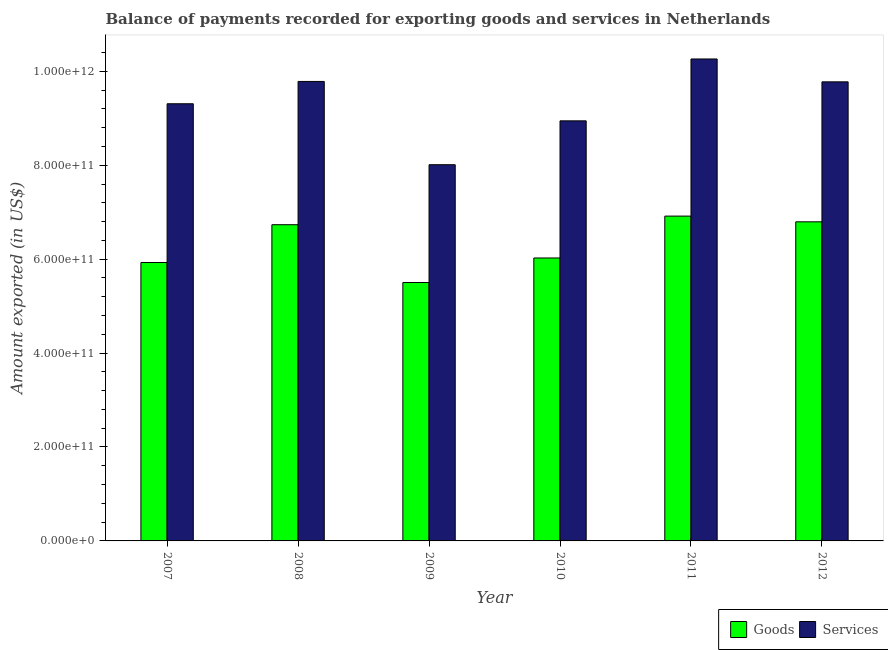How many different coloured bars are there?
Ensure brevity in your answer.  2. Are the number of bars per tick equal to the number of legend labels?
Keep it short and to the point. Yes. Are the number of bars on each tick of the X-axis equal?
Ensure brevity in your answer.  Yes. What is the label of the 3rd group of bars from the left?
Offer a very short reply. 2009. What is the amount of goods exported in 2011?
Your response must be concise. 6.92e+11. Across all years, what is the maximum amount of goods exported?
Provide a succinct answer. 6.92e+11. Across all years, what is the minimum amount of services exported?
Your answer should be compact. 8.01e+11. In which year was the amount of services exported maximum?
Offer a very short reply. 2011. What is the total amount of goods exported in the graph?
Keep it short and to the point. 3.79e+12. What is the difference between the amount of services exported in 2007 and that in 2012?
Provide a succinct answer. -4.67e+1. What is the difference between the amount of services exported in 2012 and the amount of goods exported in 2007?
Provide a succinct answer. 4.67e+1. What is the average amount of goods exported per year?
Provide a succinct answer. 6.32e+11. What is the ratio of the amount of goods exported in 2007 to that in 2011?
Your answer should be compact. 0.86. What is the difference between the highest and the second highest amount of goods exported?
Your answer should be compact. 1.22e+1. What is the difference between the highest and the lowest amount of goods exported?
Your response must be concise. 1.41e+11. In how many years, is the amount of services exported greater than the average amount of services exported taken over all years?
Offer a very short reply. 3. What does the 1st bar from the left in 2009 represents?
Your answer should be compact. Goods. What does the 2nd bar from the right in 2007 represents?
Your answer should be compact. Goods. How many bars are there?
Your answer should be very brief. 12. Are all the bars in the graph horizontal?
Your answer should be compact. No. How many years are there in the graph?
Give a very brief answer. 6. What is the difference between two consecutive major ticks on the Y-axis?
Provide a short and direct response. 2.00e+11. Are the values on the major ticks of Y-axis written in scientific E-notation?
Give a very brief answer. Yes. Where does the legend appear in the graph?
Your answer should be compact. Bottom right. How many legend labels are there?
Provide a short and direct response. 2. How are the legend labels stacked?
Provide a succinct answer. Horizontal. What is the title of the graph?
Keep it short and to the point. Balance of payments recorded for exporting goods and services in Netherlands. Does "Start a business" appear as one of the legend labels in the graph?
Your response must be concise. No. What is the label or title of the X-axis?
Provide a short and direct response. Year. What is the label or title of the Y-axis?
Provide a short and direct response. Amount exported (in US$). What is the Amount exported (in US$) of Goods in 2007?
Your answer should be compact. 5.93e+11. What is the Amount exported (in US$) of Services in 2007?
Provide a short and direct response. 9.31e+11. What is the Amount exported (in US$) of Goods in 2008?
Ensure brevity in your answer.  6.73e+11. What is the Amount exported (in US$) of Services in 2008?
Provide a succinct answer. 9.78e+11. What is the Amount exported (in US$) in Goods in 2009?
Your response must be concise. 5.50e+11. What is the Amount exported (in US$) in Services in 2009?
Provide a short and direct response. 8.01e+11. What is the Amount exported (in US$) in Goods in 2010?
Make the answer very short. 6.03e+11. What is the Amount exported (in US$) in Services in 2010?
Provide a short and direct response. 8.95e+11. What is the Amount exported (in US$) in Goods in 2011?
Your answer should be compact. 6.92e+11. What is the Amount exported (in US$) of Services in 2011?
Your response must be concise. 1.03e+12. What is the Amount exported (in US$) in Goods in 2012?
Offer a very short reply. 6.79e+11. What is the Amount exported (in US$) of Services in 2012?
Provide a succinct answer. 9.78e+11. Across all years, what is the maximum Amount exported (in US$) in Goods?
Your answer should be compact. 6.92e+11. Across all years, what is the maximum Amount exported (in US$) in Services?
Offer a very short reply. 1.03e+12. Across all years, what is the minimum Amount exported (in US$) of Goods?
Offer a terse response. 5.50e+11. Across all years, what is the minimum Amount exported (in US$) in Services?
Keep it short and to the point. 8.01e+11. What is the total Amount exported (in US$) in Goods in the graph?
Provide a succinct answer. 3.79e+12. What is the total Amount exported (in US$) in Services in the graph?
Your answer should be compact. 5.61e+12. What is the difference between the Amount exported (in US$) in Goods in 2007 and that in 2008?
Offer a very short reply. -8.05e+1. What is the difference between the Amount exported (in US$) of Services in 2007 and that in 2008?
Your answer should be very brief. -4.75e+1. What is the difference between the Amount exported (in US$) of Goods in 2007 and that in 2009?
Your answer should be very brief. 4.26e+1. What is the difference between the Amount exported (in US$) in Services in 2007 and that in 2009?
Make the answer very short. 1.30e+11. What is the difference between the Amount exported (in US$) in Goods in 2007 and that in 2010?
Offer a very short reply. -9.65e+09. What is the difference between the Amount exported (in US$) of Services in 2007 and that in 2010?
Your answer should be compact. 3.64e+1. What is the difference between the Amount exported (in US$) of Goods in 2007 and that in 2011?
Your response must be concise. -9.88e+1. What is the difference between the Amount exported (in US$) in Services in 2007 and that in 2011?
Keep it short and to the point. -9.54e+1. What is the difference between the Amount exported (in US$) in Goods in 2007 and that in 2012?
Your answer should be very brief. -8.66e+1. What is the difference between the Amount exported (in US$) of Services in 2007 and that in 2012?
Your response must be concise. -4.67e+1. What is the difference between the Amount exported (in US$) of Goods in 2008 and that in 2009?
Your answer should be very brief. 1.23e+11. What is the difference between the Amount exported (in US$) in Services in 2008 and that in 2009?
Your answer should be very brief. 1.77e+11. What is the difference between the Amount exported (in US$) of Goods in 2008 and that in 2010?
Make the answer very short. 7.08e+1. What is the difference between the Amount exported (in US$) of Services in 2008 and that in 2010?
Provide a succinct answer. 8.39e+1. What is the difference between the Amount exported (in US$) of Goods in 2008 and that in 2011?
Provide a short and direct response. -1.83e+1. What is the difference between the Amount exported (in US$) of Services in 2008 and that in 2011?
Offer a terse response. -4.79e+1. What is the difference between the Amount exported (in US$) in Goods in 2008 and that in 2012?
Provide a succinct answer. -6.14e+09. What is the difference between the Amount exported (in US$) in Services in 2008 and that in 2012?
Offer a very short reply. 8.37e+08. What is the difference between the Amount exported (in US$) of Goods in 2009 and that in 2010?
Your answer should be compact. -5.22e+1. What is the difference between the Amount exported (in US$) of Services in 2009 and that in 2010?
Ensure brevity in your answer.  -9.34e+1. What is the difference between the Amount exported (in US$) of Goods in 2009 and that in 2011?
Offer a terse response. -1.41e+11. What is the difference between the Amount exported (in US$) of Services in 2009 and that in 2011?
Your answer should be very brief. -2.25e+11. What is the difference between the Amount exported (in US$) of Goods in 2009 and that in 2012?
Provide a succinct answer. -1.29e+11. What is the difference between the Amount exported (in US$) of Services in 2009 and that in 2012?
Give a very brief answer. -1.76e+11. What is the difference between the Amount exported (in US$) in Goods in 2010 and that in 2011?
Your answer should be very brief. -8.92e+1. What is the difference between the Amount exported (in US$) in Services in 2010 and that in 2011?
Provide a succinct answer. -1.32e+11. What is the difference between the Amount exported (in US$) in Goods in 2010 and that in 2012?
Provide a succinct answer. -7.70e+1. What is the difference between the Amount exported (in US$) in Services in 2010 and that in 2012?
Your answer should be compact. -8.30e+1. What is the difference between the Amount exported (in US$) in Goods in 2011 and that in 2012?
Provide a succinct answer. 1.22e+1. What is the difference between the Amount exported (in US$) in Services in 2011 and that in 2012?
Provide a succinct answer. 4.87e+1. What is the difference between the Amount exported (in US$) in Goods in 2007 and the Amount exported (in US$) in Services in 2008?
Make the answer very short. -3.86e+11. What is the difference between the Amount exported (in US$) of Goods in 2007 and the Amount exported (in US$) of Services in 2009?
Provide a succinct answer. -2.08e+11. What is the difference between the Amount exported (in US$) of Goods in 2007 and the Amount exported (in US$) of Services in 2010?
Keep it short and to the point. -3.02e+11. What is the difference between the Amount exported (in US$) of Goods in 2007 and the Amount exported (in US$) of Services in 2011?
Make the answer very short. -4.33e+11. What is the difference between the Amount exported (in US$) in Goods in 2007 and the Amount exported (in US$) in Services in 2012?
Your response must be concise. -3.85e+11. What is the difference between the Amount exported (in US$) of Goods in 2008 and the Amount exported (in US$) of Services in 2009?
Give a very brief answer. -1.28e+11. What is the difference between the Amount exported (in US$) of Goods in 2008 and the Amount exported (in US$) of Services in 2010?
Provide a succinct answer. -2.21e+11. What is the difference between the Amount exported (in US$) in Goods in 2008 and the Amount exported (in US$) in Services in 2011?
Offer a very short reply. -3.53e+11. What is the difference between the Amount exported (in US$) in Goods in 2008 and the Amount exported (in US$) in Services in 2012?
Provide a succinct answer. -3.04e+11. What is the difference between the Amount exported (in US$) in Goods in 2009 and the Amount exported (in US$) in Services in 2010?
Your answer should be compact. -3.44e+11. What is the difference between the Amount exported (in US$) in Goods in 2009 and the Amount exported (in US$) in Services in 2011?
Provide a short and direct response. -4.76e+11. What is the difference between the Amount exported (in US$) in Goods in 2009 and the Amount exported (in US$) in Services in 2012?
Your answer should be very brief. -4.27e+11. What is the difference between the Amount exported (in US$) in Goods in 2010 and the Amount exported (in US$) in Services in 2011?
Your answer should be very brief. -4.24e+11. What is the difference between the Amount exported (in US$) in Goods in 2010 and the Amount exported (in US$) in Services in 2012?
Make the answer very short. -3.75e+11. What is the difference between the Amount exported (in US$) of Goods in 2011 and the Amount exported (in US$) of Services in 2012?
Ensure brevity in your answer.  -2.86e+11. What is the average Amount exported (in US$) of Goods per year?
Give a very brief answer. 6.32e+11. What is the average Amount exported (in US$) of Services per year?
Your answer should be compact. 9.35e+11. In the year 2007, what is the difference between the Amount exported (in US$) of Goods and Amount exported (in US$) of Services?
Give a very brief answer. -3.38e+11. In the year 2008, what is the difference between the Amount exported (in US$) in Goods and Amount exported (in US$) in Services?
Make the answer very short. -3.05e+11. In the year 2009, what is the difference between the Amount exported (in US$) in Goods and Amount exported (in US$) in Services?
Offer a terse response. -2.51e+11. In the year 2010, what is the difference between the Amount exported (in US$) of Goods and Amount exported (in US$) of Services?
Ensure brevity in your answer.  -2.92e+11. In the year 2011, what is the difference between the Amount exported (in US$) in Goods and Amount exported (in US$) in Services?
Your response must be concise. -3.35e+11. In the year 2012, what is the difference between the Amount exported (in US$) in Goods and Amount exported (in US$) in Services?
Ensure brevity in your answer.  -2.98e+11. What is the ratio of the Amount exported (in US$) in Goods in 2007 to that in 2008?
Ensure brevity in your answer.  0.88. What is the ratio of the Amount exported (in US$) of Services in 2007 to that in 2008?
Offer a terse response. 0.95. What is the ratio of the Amount exported (in US$) of Goods in 2007 to that in 2009?
Ensure brevity in your answer.  1.08. What is the ratio of the Amount exported (in US$) in Services in 2007 to that in 2009?
Offer a terse response. 1.16. What is the ratio of the Amount exported (in US$) of Services in 2007 to that in 2010?
Your answer should be compact. 1.04. What is the ratio of the Amount exported (in US$) of Goods in 2007 to that in 2011?
Your answer should be compact. 0.86. What is the ratio of the Amount exported (in US$) of Services in 2007 to that in 2011?
Provide a succinct answer. 0.91. What is the ratio of the Amount exported (in US$) in Goods in 2007 to that in 2012?
Your answer should be very brief. 0.87. What is the ratio of the Amount exported (in US$) of Services in 2007 to that in 2012?
Offer a terse response. 0.95. What is the ratio of the Amount exported (in US$) of Goods in 2008 to that in 2009?
Provide a succinct answer. 1.22. What is the ratio of the Amount exported (in US$) in Services in 2008 to that in 2009?
Your answer should be compact. 1.22. What is the ratio of the Amount exported (in US$) of Goods in 2008 to that in 2010?
Ensure brevity in your answer.  1.12. What is the ratio of the Amount exported (in US$) of Services in 2008 to that in 2010?
Give a very brief answer. 1.09. What is the ratio of the Amount exported (in US$) in Goods in 2008 to that in 2011?
Your answer should be compact. 0.97. What is the ratio of the Amount exported (in US$) in Services in 2008 to that in 2011?
Make the answer very short. 0.95. What is the ratio of the Amount exported (in US$) of Goods in 2008 to that in 2012?
Your response must be concise. 0.99. What is the ratio of the Amount exported (in US$) of Services in 2008 to that in 2012?
Your answer should be compact. 1. What is the ratio of the Amount exported (in US$) in Goods in 2009 to that in 2010?
Offer a terse response. 0.91. What is the ratio of the Amount exported (in US$) of Services in 2009 to that in 2010?
Keep it short and to the point. 0.9. What is the ratio of the Amount exported (in US$) of Goods in 2009 to that in 2011?
Give a very brief answer. 0.8. What is the ratio of the Amount exported (in US$) in Services in 2009 to that in 2011?
Keep it short and to the point. 0.78. What is the ratio of the Amount exported (in US$) in Goods in 2009 to that in 2012?
Provide a short and direct response. 0.81. What is the ratio of the Amount exported (in US$) of Services in 2009 to that in 2012?
Make the answer very short. 0.82. What is the ratio of the Amount exported (in US$) of Goods in 2010 to that in 2011?
Your response must be concise. 0.87. What is the ratio of the Amount exported (in US$) of Services in 2010 to that in 2011?
Give a very brief answer. 0.87. What is the ratio of the Amount exported (in US$) in Goods in 2010 to that in 2012?
Your response must be concise. 0.89. What is the ratio of the Amount exported (in US$) of Services in 2010 to that in 2012?
Make the answer very short. 0.92. What is the ratio of the Amount exported (in US$) in Goods in 2011 to that in 2012?
Keep it short and to the point. 1.02. What is the ratio of the Amount exported (in US$) of Services in 2011 to that in 2012?
Your response must be concise. 1.05. What is the difference between the highest and the second highest Amount exported (in US$) in Goods?
Provide a short and direct response. 1.22e+1. What is the difference between the highest and the second highest Amount exported (in US$) of Services?
Your response must be concise. 4.79e+1. What is the difference between the highest and the lowest Amount exported (in US$) of Goods?
Your answer should be very brief. 1.41e+11. What is the difference between the highest and the lowest Amount exported (in US$) in Services?
Your response must be concise. 2.25e+11. 